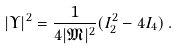<formula> <loc_0><loc_0><loc_500><loc_500>| \Upsilon | ^ { 2 } = \frac { 1 } { 4 | \mathfrak { M } | ^ { 2 } } ( I _ { 2 } ^ { 2 } - 4 I _ { 4 } ) \, .</formula> 